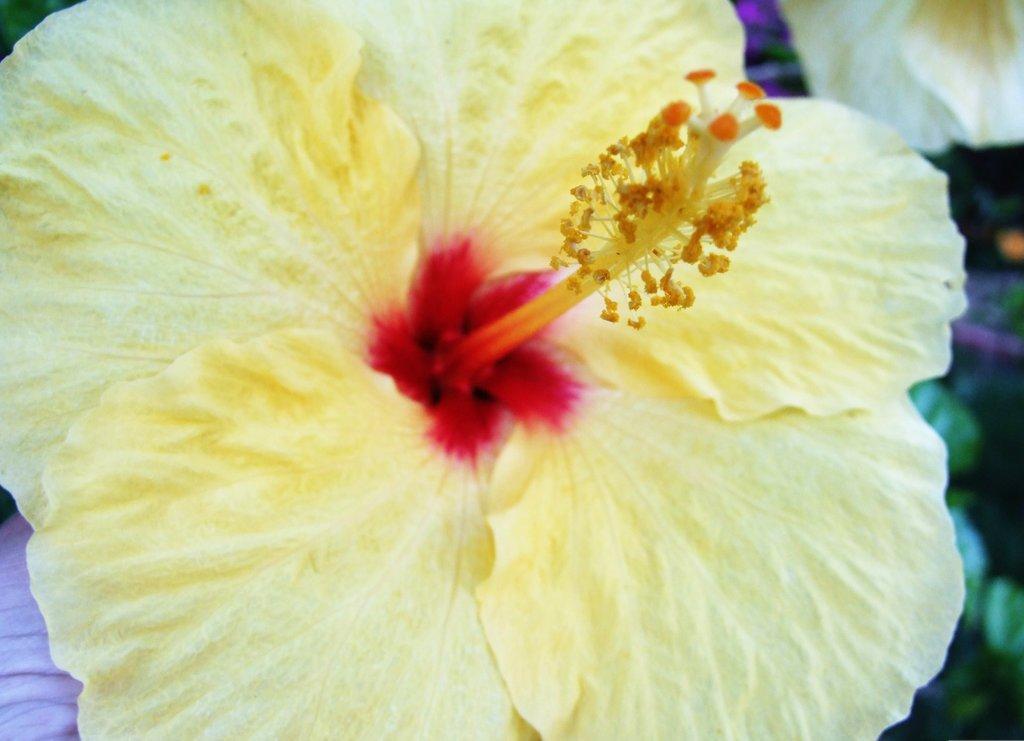Could you give a brief overview of what you see in this image? In this image there is a flower. 